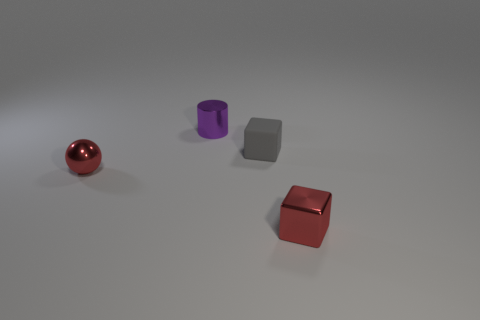There is a block that is left of the metallic thing that is to the right of the matte thing; what number of red objects are left of it? To the left of the block, which is situated to the right of the matte object (a purple cylinder), there is one red object, which appears to be a reflective, spherical ornament. 